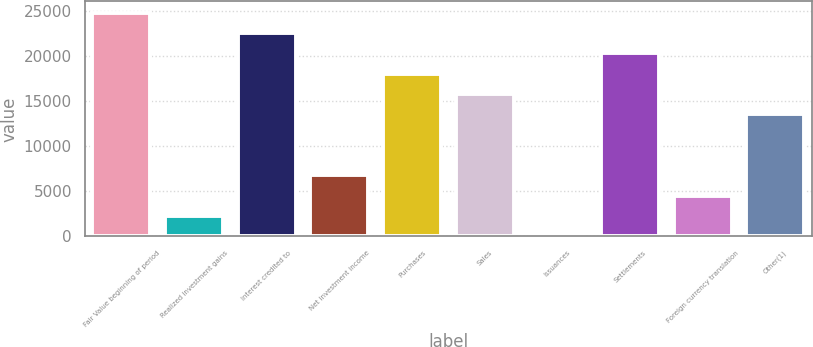Convert chart. <chart><loc_0><loc_0><loc_500><loc_500><bar_chart><fcel>Fair Value beginning of period<fcel>Realized investment gains<fcel>Interest credited to<fcel>Net investment income<fcel>Purchases<fcel>Sales<fcel>Issuances<fcel>Settlements<fcel>Foreign currency translation<fcel>Other(1)<nl><fcel>24863.1<fcel>2261.93<fcel>22603<fcel>6782.17<fcel>18082.8<fcel>15822.6<fcel>1.81<fcel>20342.9<fcel>4522.05<fcel>13562.5<nl></chart> 